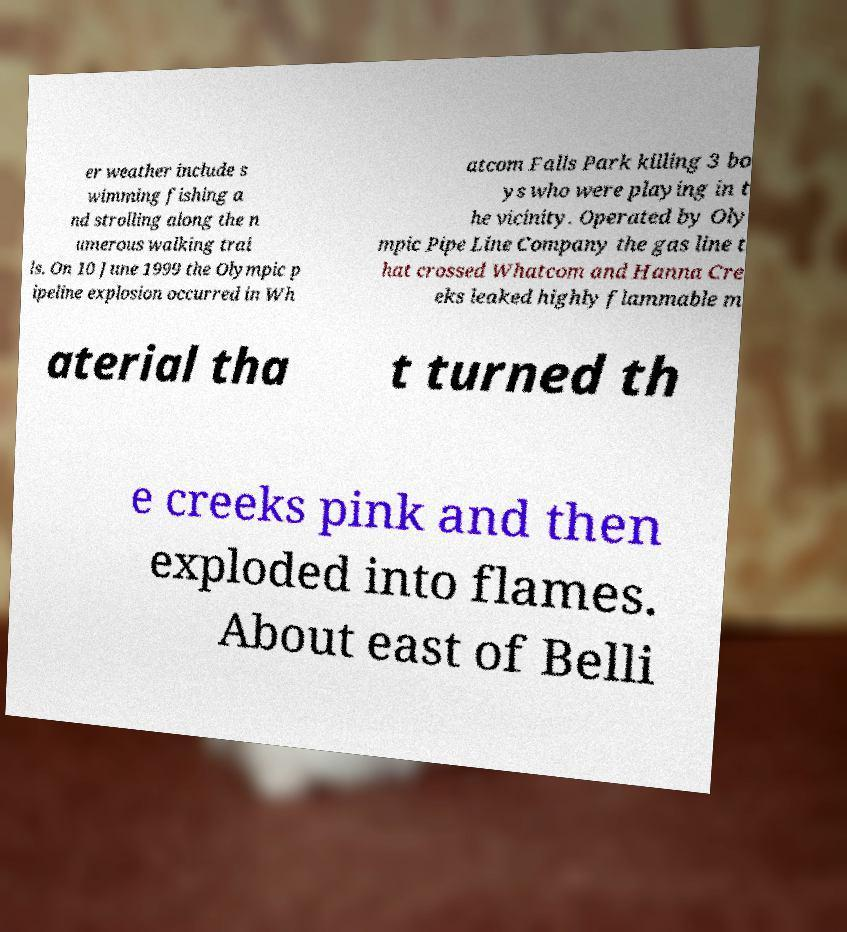For documentation purposes, I need the text within this image transcribed. Could you provide that? er weather include s wimming fishing a nd strolling along the n umerous walking trai ls. On 10 June 1999 the Olympic p ipeline explosion occurred in Wh atcom Falls Park killing 3 bo ys who were playing in t he vicinity. Operated by Oly mpic Pipe Line Company the gas line t hat crossed Whatcom and Hanna Cre eks leaked highly flammable m aterial tha t turned th e creeks pink and then exploded into flames. About east of Belli 